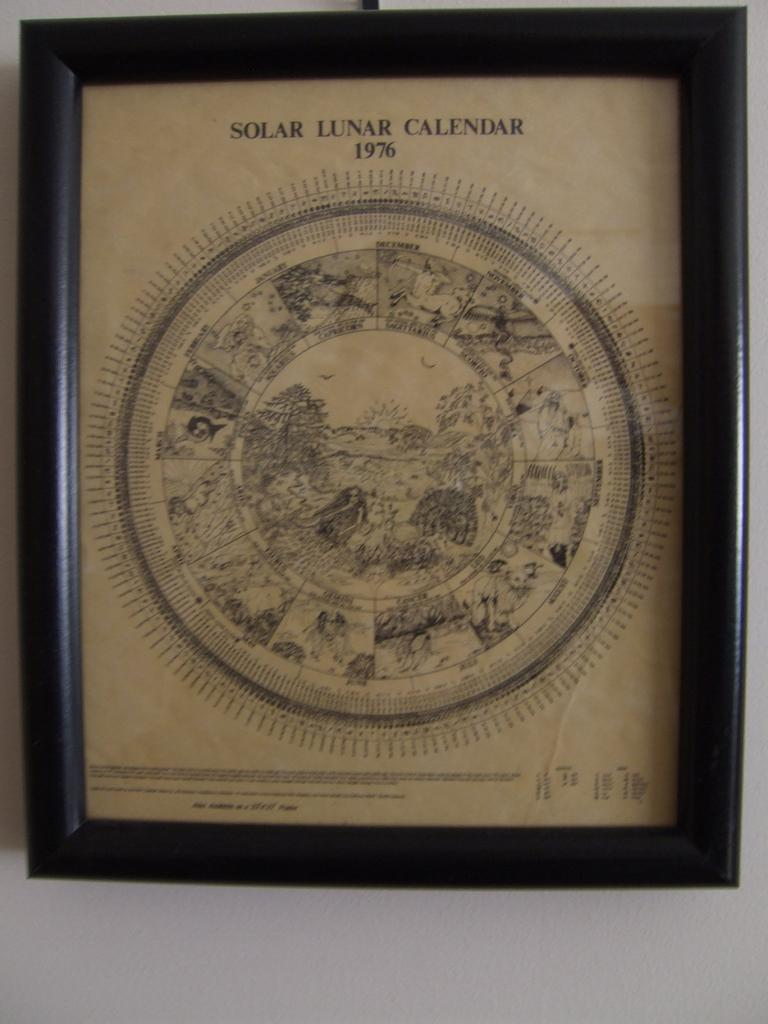<image>
Give a short and clear explanation of the subsequent image. A framed image of the 1976 solar lunar calendar. 